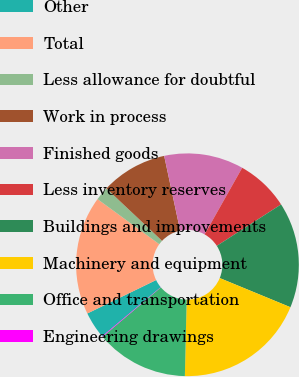Convert chart. <chart><loc_0><loc_0><loc_500><loc_500><pie_chart><fcel>Other<fcel>Total<fcel>Less allowance for doubtful<fcel>Work in process<fcel>Finished goods<fcel>Less inventory reserves<fcel>Buildings and improvements<fcel>Machinery and equipment<fcel>Office and transportation<fcel>Engineering drawings<nl><fcel>3.9%<fcel>17.24%<fcel>1.99%<fcel>9.62%<fcel>11.53%<fcel>7.71%<fcel>15.34%<fcel>19.15%<fcel>13.43%<fcel>0.09%<nl></chart> 